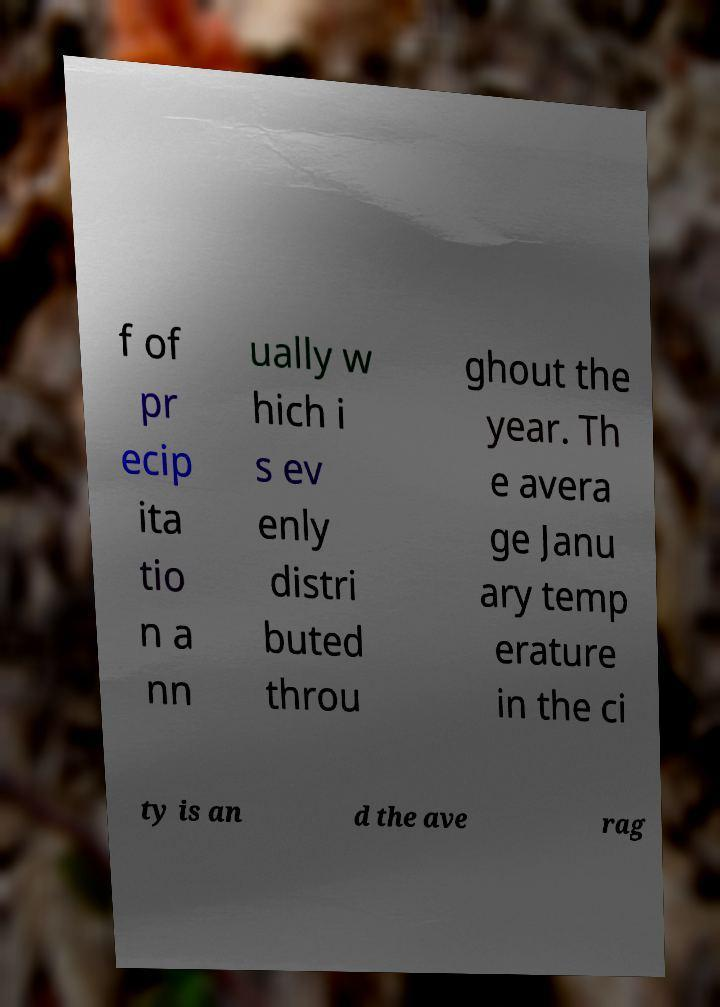Could you extract and type out the text from this image? f of pr ecip ita tio n a nn ually w hich i s ev enly distri buted throu ghout the year. Th e avera ge Janu ary temp erature in the ci ty is an d the ave rag 